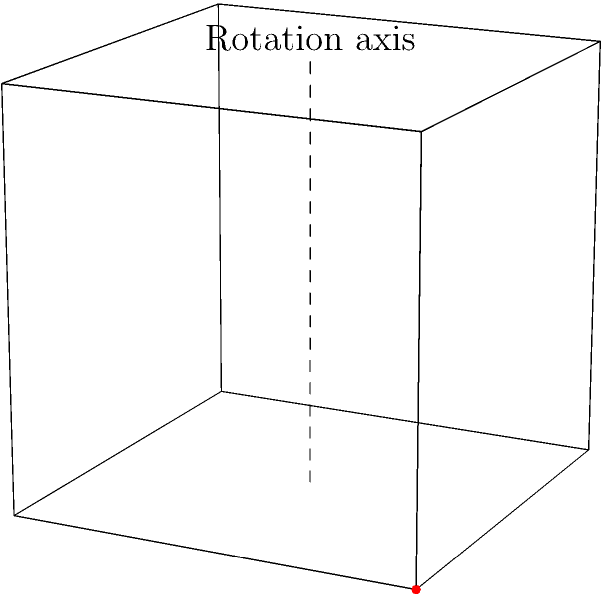A cube with a red dot on one of its corners is rotated 90 degrees clockwise around the vertical axis shown. Which of the following views represents the correct position of the red dot after rotation?

A) On the front face, top right corner
B) On the right face, top front corner
C) On the back face, top left corner
D) On the left face, top back corner Let's approach this step-by-step:

1) First, identify the initial position of the red dot. It's on the top front right corner of the cube.

2) The rotation axis is vertical, passing through the center of the cube from top to bottom.

3) A 90-degree clockwise rotation around this axis means:
   - The front face will become the right face
   - The right face will become the back face
   - The back face will become the left face
   - The left face will become the front face

4) The red dot, being on the top front right corner, will move with the front face as it becomes the right face.

5) After rotation, the red dot will be on the top front corner of what is now the right face of the cube.

Therefore, the correct position of the red dot after rotation is on the right face, at the top front corner.
Answer: B 